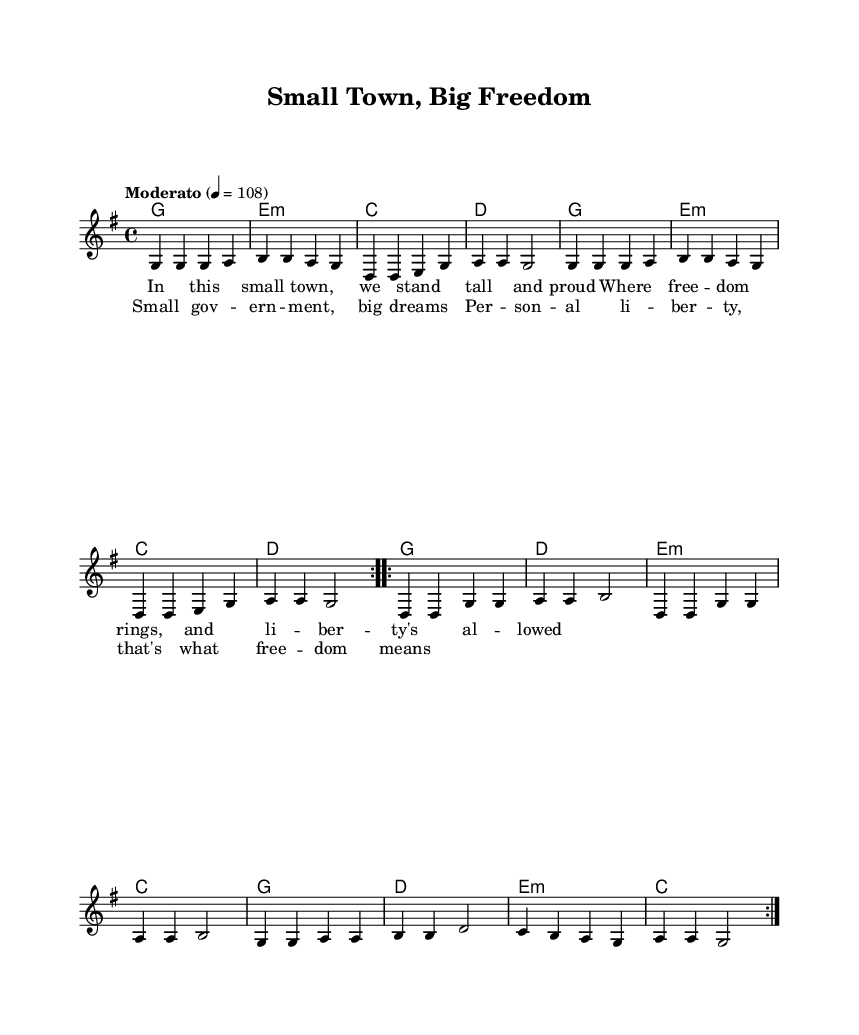What is the key signature of this music? The key signature is G major, which has one sharp (F#). This can be determined by looking at the initial part of the sheet music where the key is indicated before the time signature.
Answer: G major What is the time signature of this piece? The time signature is 4/4, which is indicated just after the key signature. It means there are four beats per measure, with each beat being a quarter note.
Answer: 4/4 What is the tempo marking for the piece? The tempo marking is "Moderato" at 108 beats per minute, as specified at the beginning of the music. This indicates a moderate speed for the performance.
Answer: Moderato 108 How many times is the verse repeated? The verse is repeated twice, as indicated by the notation "repeat volta 2" that precedes the melody part for the verse.
Answer: 2 What is the root chord of the first measure? The root chord of the first measure is G major, as seen in the chord notation at the beginning of the measure. It is the first chord listed in the harmony section.
Answer: G major What do the lyrics in the chorus emphasize about government? The lyrics in the chorus emphasize "small government" and "personal liberty," which are key themes discussed in the song regarding individual freedoms. This is derived from the text provided alongside the chorus melody.
Answer: Small government, personal liberty What is the relationship between the lyrics and the musical structure in this song? The lyrics and the musical structure are closely aligned, with each line of lyrics corresponding to specific measures of music. The lyrics express themes of freedom and government size, complementing the melody and chord progressions throughout the verse and chorus.
Answer: The lyrics align with the musical structure, expressing themes of freedom and small government 